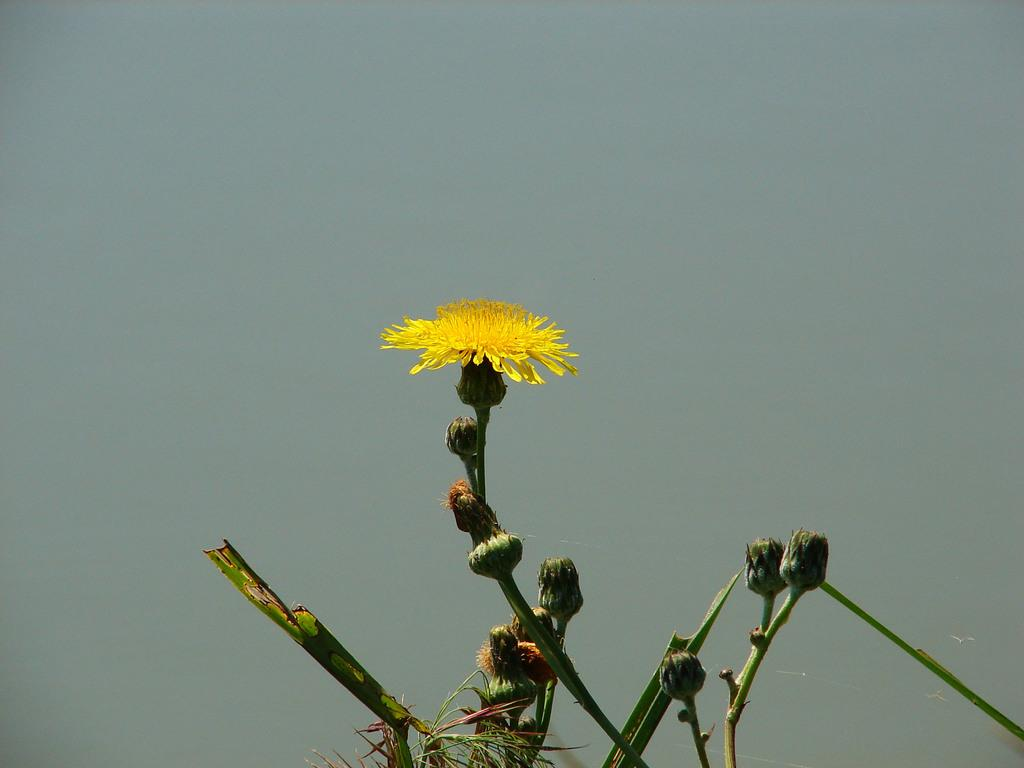What type of living organism can be seen in the picture? There is a plant in the picture. What is the plant's reproductive structure? The plant has a flower. Are there any unopened flowers on the plant? Yes, there are buds on the plant. What is the condition of the sky in the picture? The sky is clear in the picture. What type of nail is being used to play basketball during the meeting in the image? There is no nail, basketball, or meeting present in the image; it features a plant with a flower and buds. 